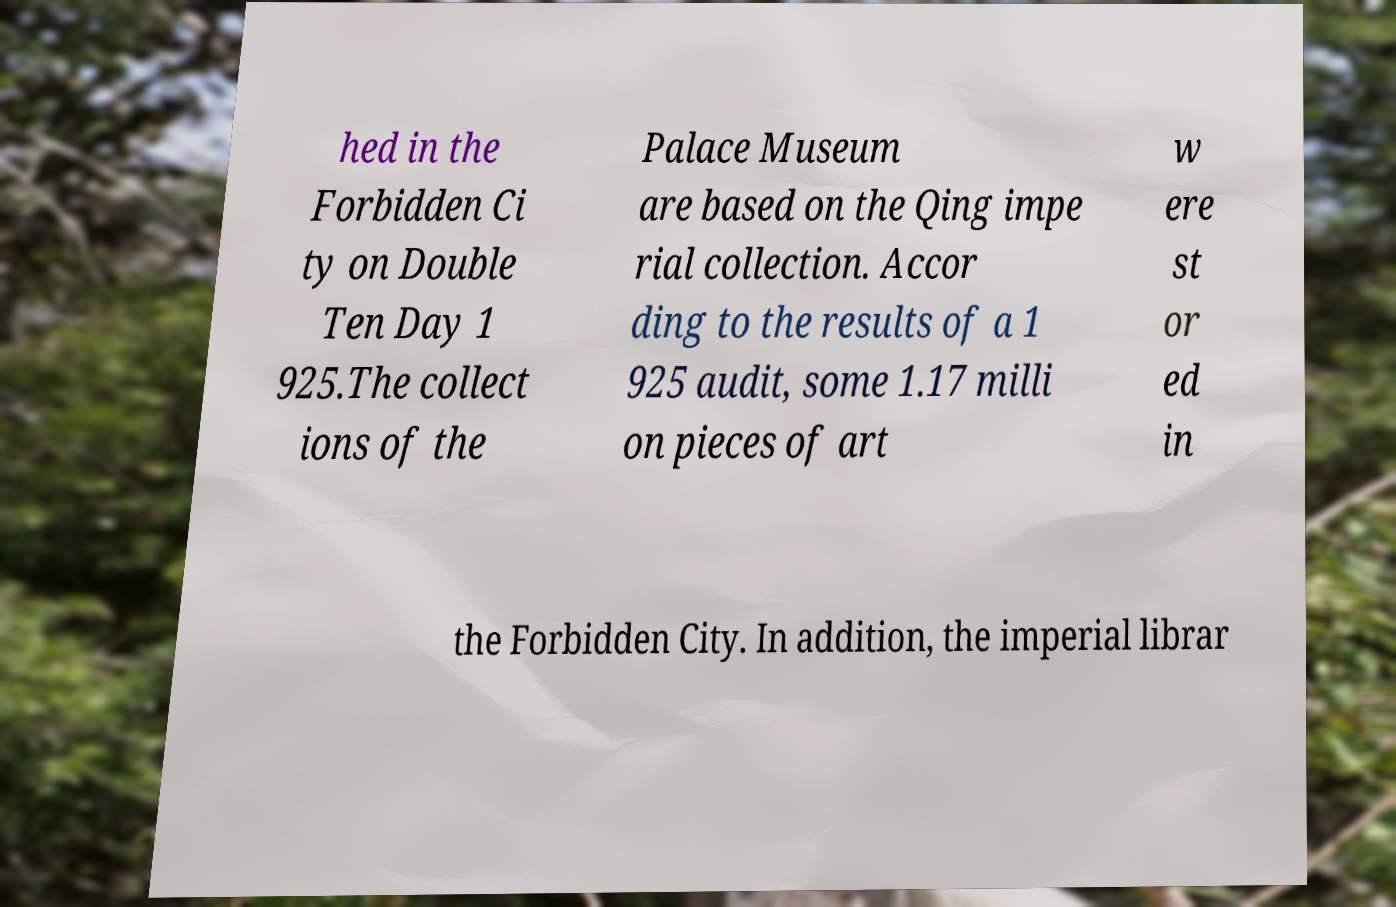Can you accurately transcribe the text from the provided image for me? hed in the Forbidden Ci ty on Double Ten Day 1 925.The collect ions of the Palace Museum are based on the Qing impe rial collection. Accor ding to the results of a 1 925 audit, some 1.17 milli on pieces of art w ere st or ed in the Forbidden City. In addition, the imperial librar 